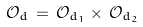<formula> <loc_0><loc_0><loc_500><loc_500>\mathcal { O } _ { d } \, = \, \mathcal { O } _ { d _ { 1 } } \times \, \mathcal { O } _ { d _ { 2 } }</formula> 